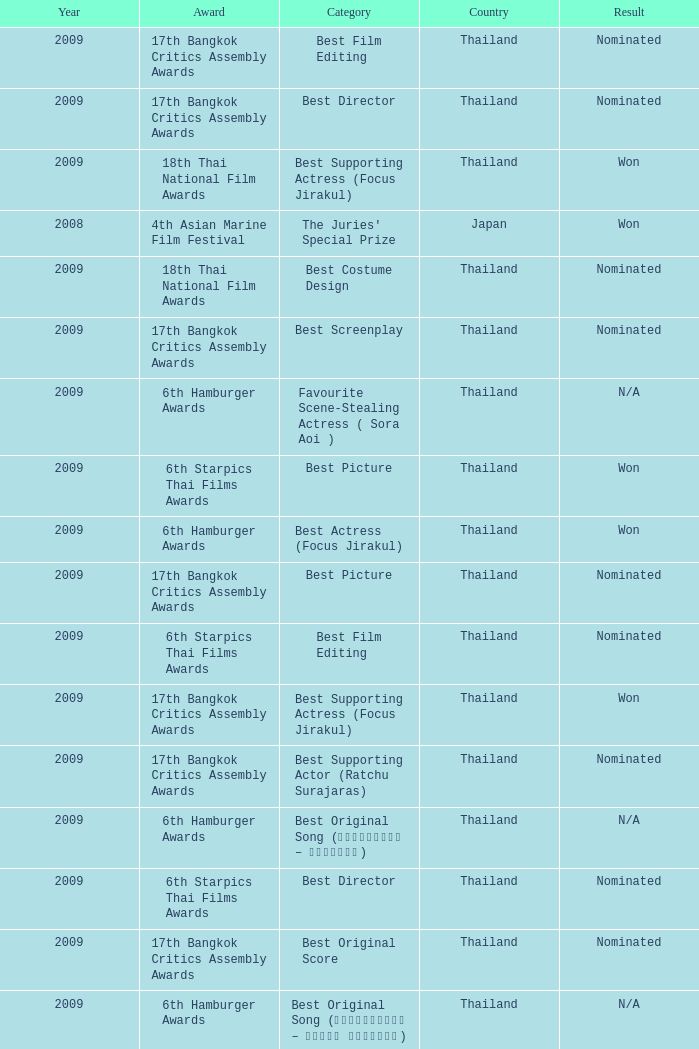Which Year has an Award of 17th bangkok critics assembly awards, and a Category of best original score? 2009.0. 